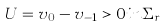Convert formula to latex. <formula><loc_0><loc_0><loc_500><loc_500>U = v _ { 0 } - v _ { - 1 } > 0 i n \Sigma _ { r }</formula> 